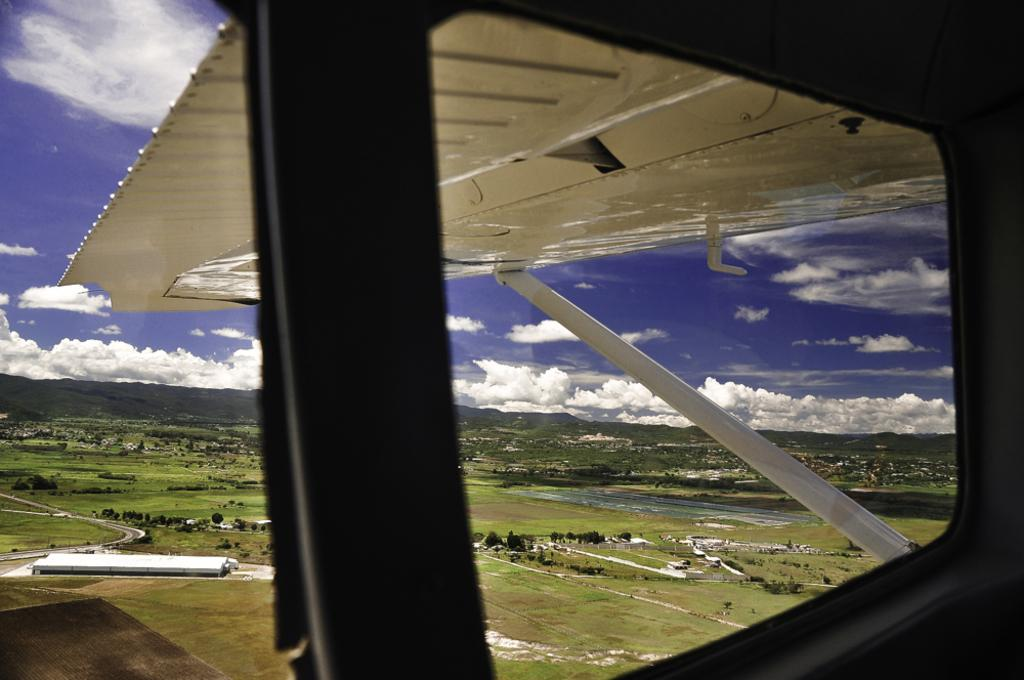What is located in the center of the image? There is a window in the center of the image. What can be seen at the bottom of the image? There is grass at the bottom of the image. What type of vegetation is present in the image? There are trees in the image. What type of jar can be seen in the image? There is no jar present in the image. 